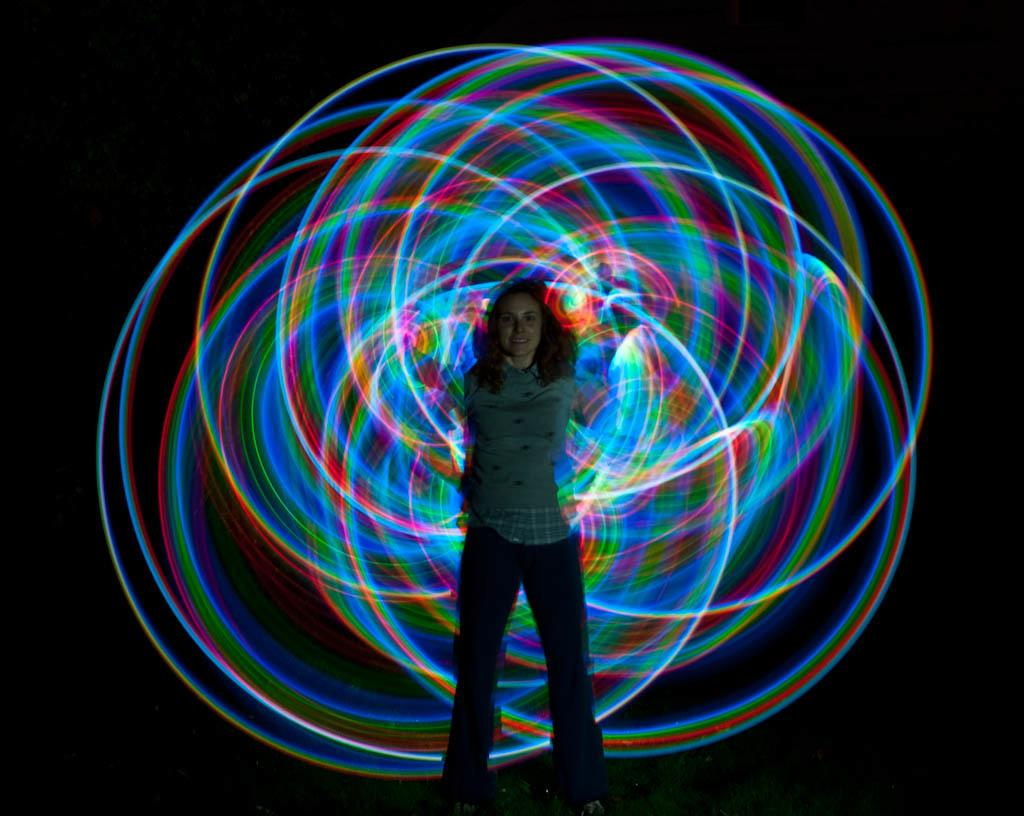Who is the main subject in the image? There is a woman in the image. Where is the woman positioned in the image? The woman is standing in the center of the image. What surface is the woman standing on? The woman is standing on the ground. What type of iron is the woman using to drive in the image? There is no iron or driving activity present in the image; it features a woman standing on the ground. 